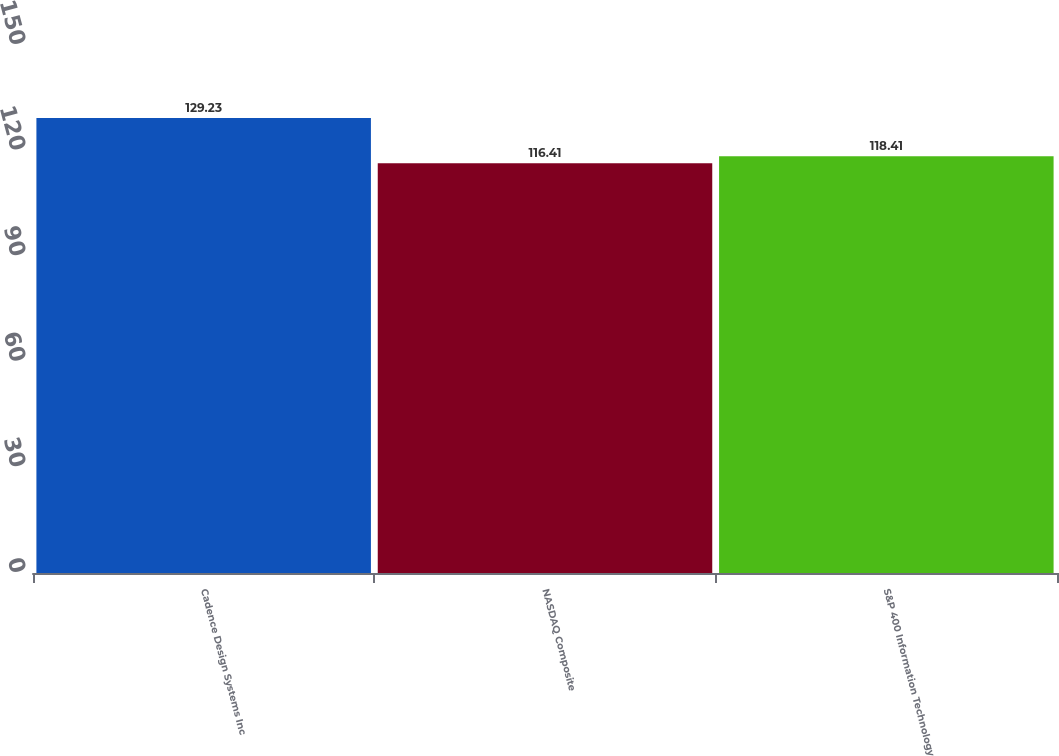Convert chart. <chart><loc_0><loc_0><loc_500><loc_500><bar_chart><fcel>Cadence Design Systems Inc<fcel>NASDAQ Composite<fcel>S&P 400 Information Technology<nl><fcel>129.23<fcel>116.41<fcel>118.41<nl></chart> 